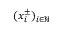<formula> <loc_0><loc_0><loc_500><loc_500>( x _ { i } ^ { \pm } ) _ { i \in \mathbb { N } }</formula> 